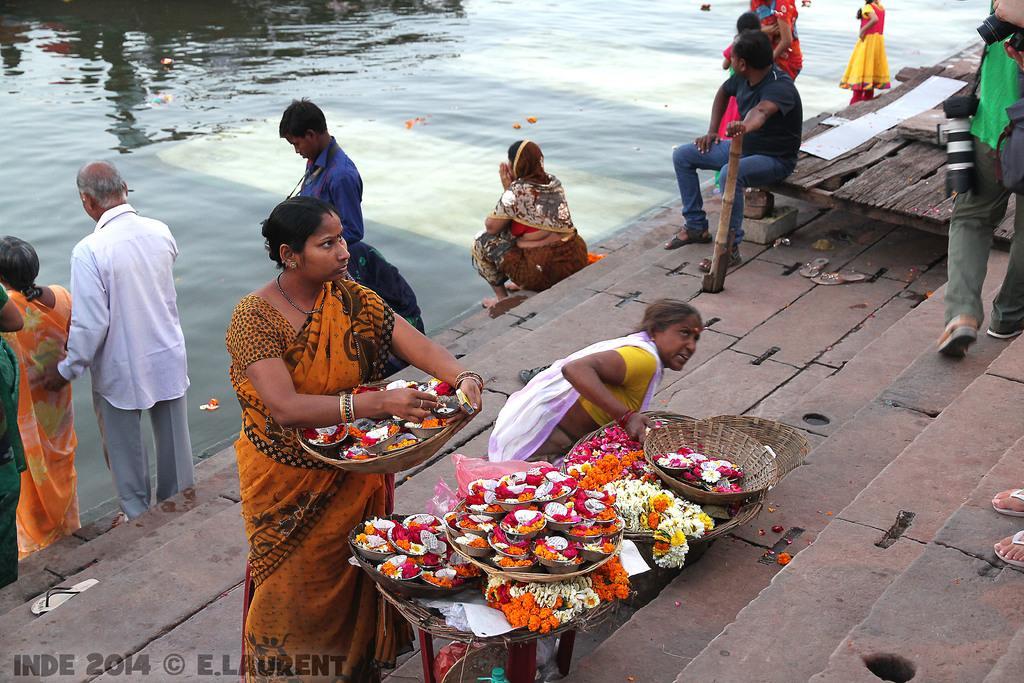Could you give a brief overview of what you see in this image? In this image there is a table on that table there are baskets in that baskets there are flower and a woman is holding a basket in that basket there are flowers, in the background there are people standing and there is a river, in the top right there is a table on that table there is a man sitting. 